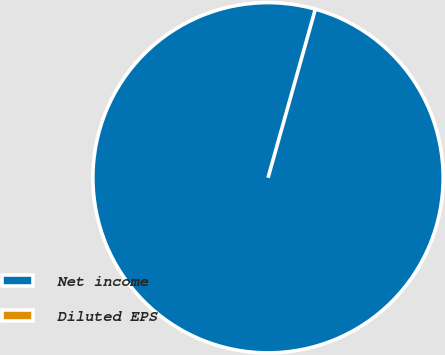Convert chart to OTSL. <chart><loc_0><loc_0><loc_500><loc_500><pie_chart><fcel>Net income<fcel>Diluted EPS<nl><fcel>100.0%<fcel>0.0%<nl></chart> 